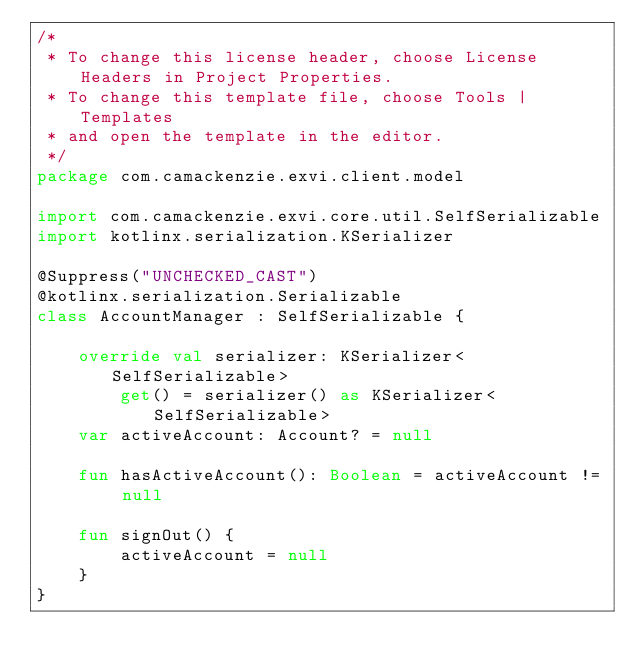<code> <loc_0><loc_0><loc_500><loc_500><_Kotlin_>/*
 * To change this license header, choose License Headers in Project Properties.
 * To change this template file, choose Tools | Templates
 * and open the template in the editor.
 */
package com.camackenzie.exvi.client.model

import com.camackenzie.exvi.core.util.SelfSerializable
import kotlinx.serialization.KSerializer

@Suppress("UNCHECKED_CAST")
@kotlinx.serialization.Serializable
class AccountManager : SelfSerializable {

    override val serializer: KSerializer<SelfSerializable>
        get() = serializer() as KSerializer<SelfSerializable>
    var activeAccount: Account? = null

    fun hasActiveAccount(): Boolean = activeAccount != null

    fun signOut() {
        activeAccount = null
    }
}</code> 